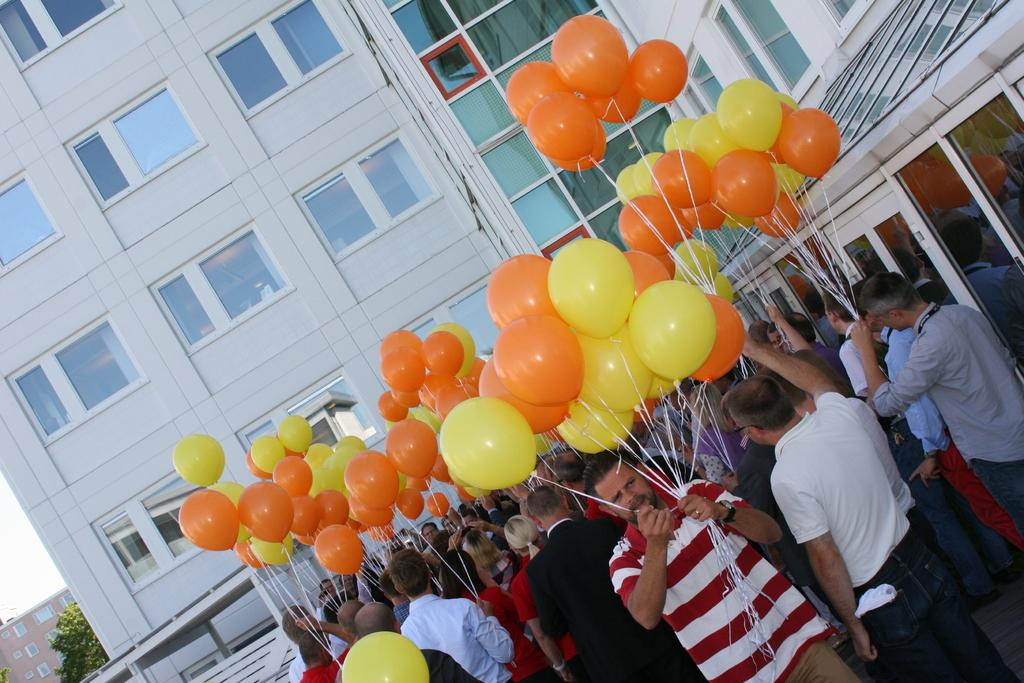What is happening in the image involving the group of people? The people in the image are standing and holding balloons. What can be seen in the background of the image? There are buildings, trees, and the sky visible in the background of the image. What type of ornament is hanging from the trees in the image? There is no ornament hanging from the trees in the image; only buildings, trees, and the sky are visible in the background. What statement can be made about the cleanliness of the ground in the image? The provided facts do not mention the cleanliness of the ground, so it cannot be determined from the image. 